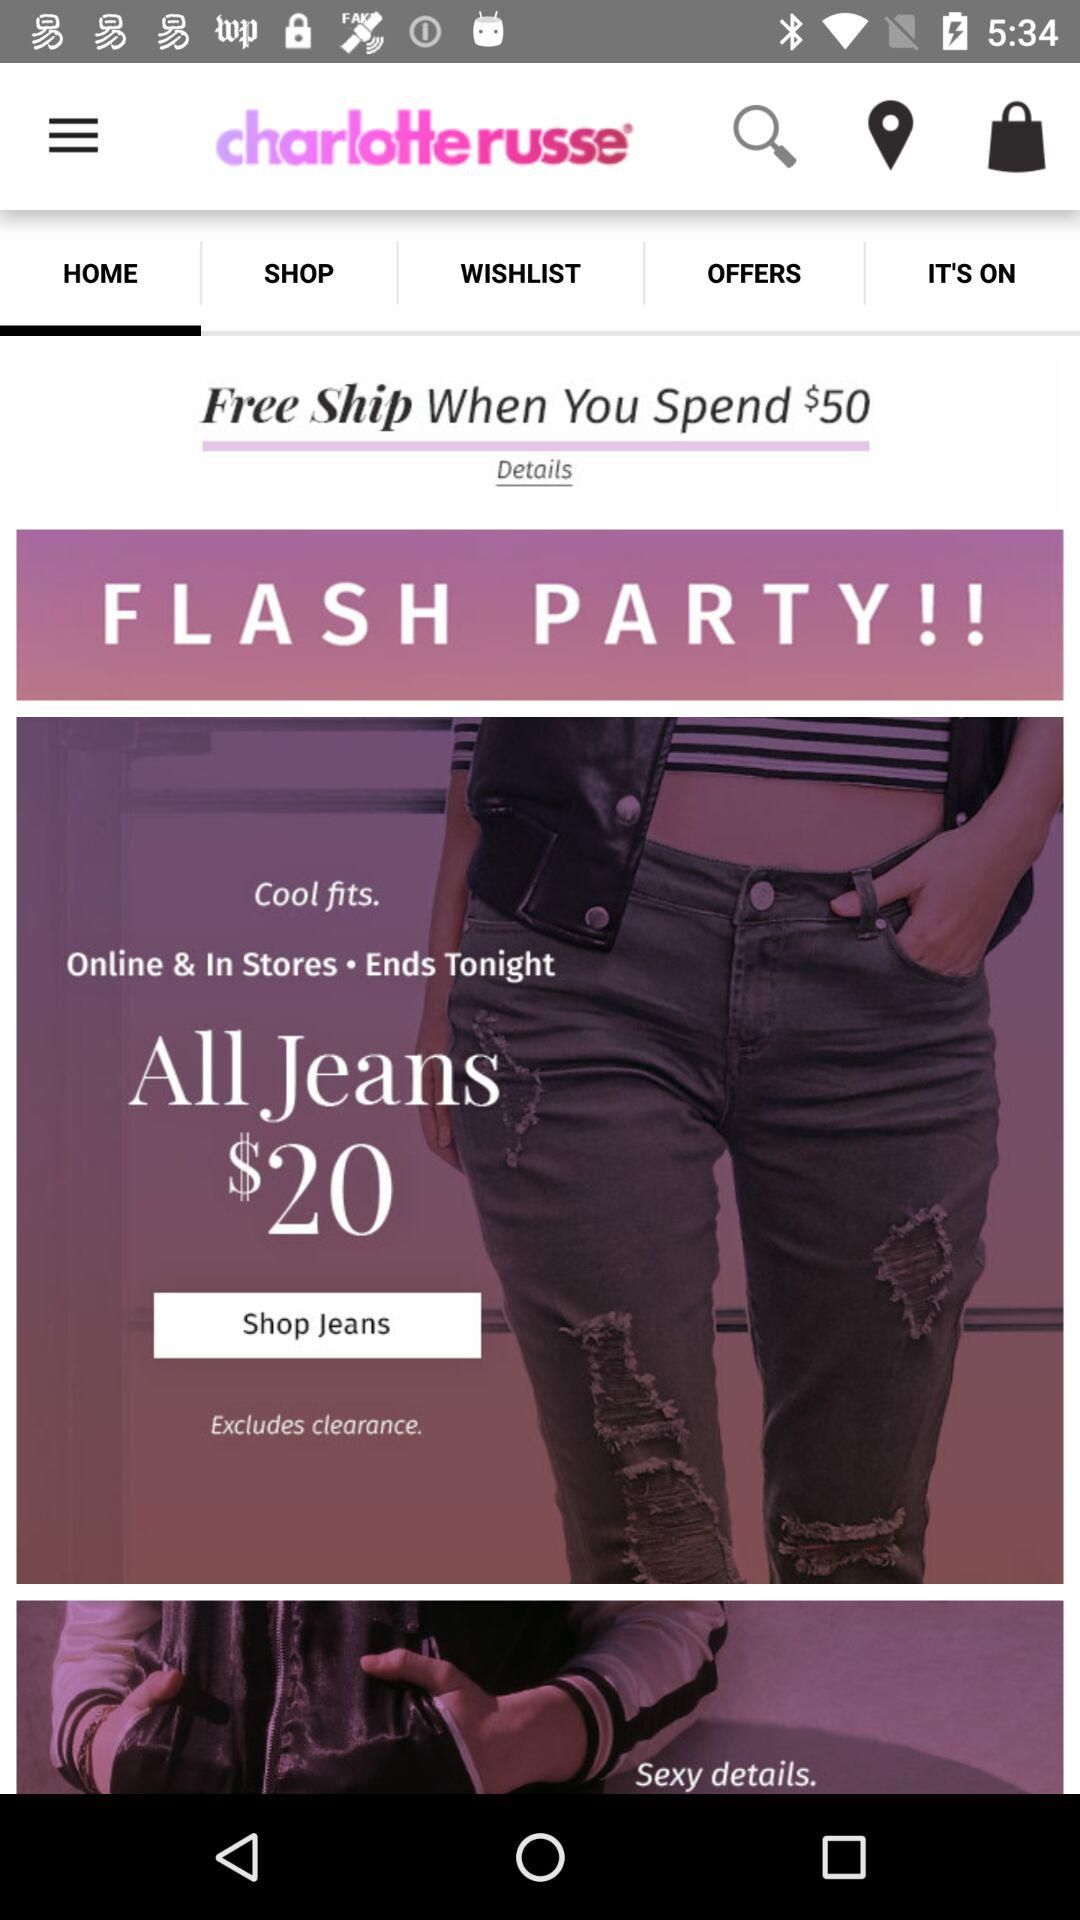Which tab is selected? The selected tab is "HOME". 